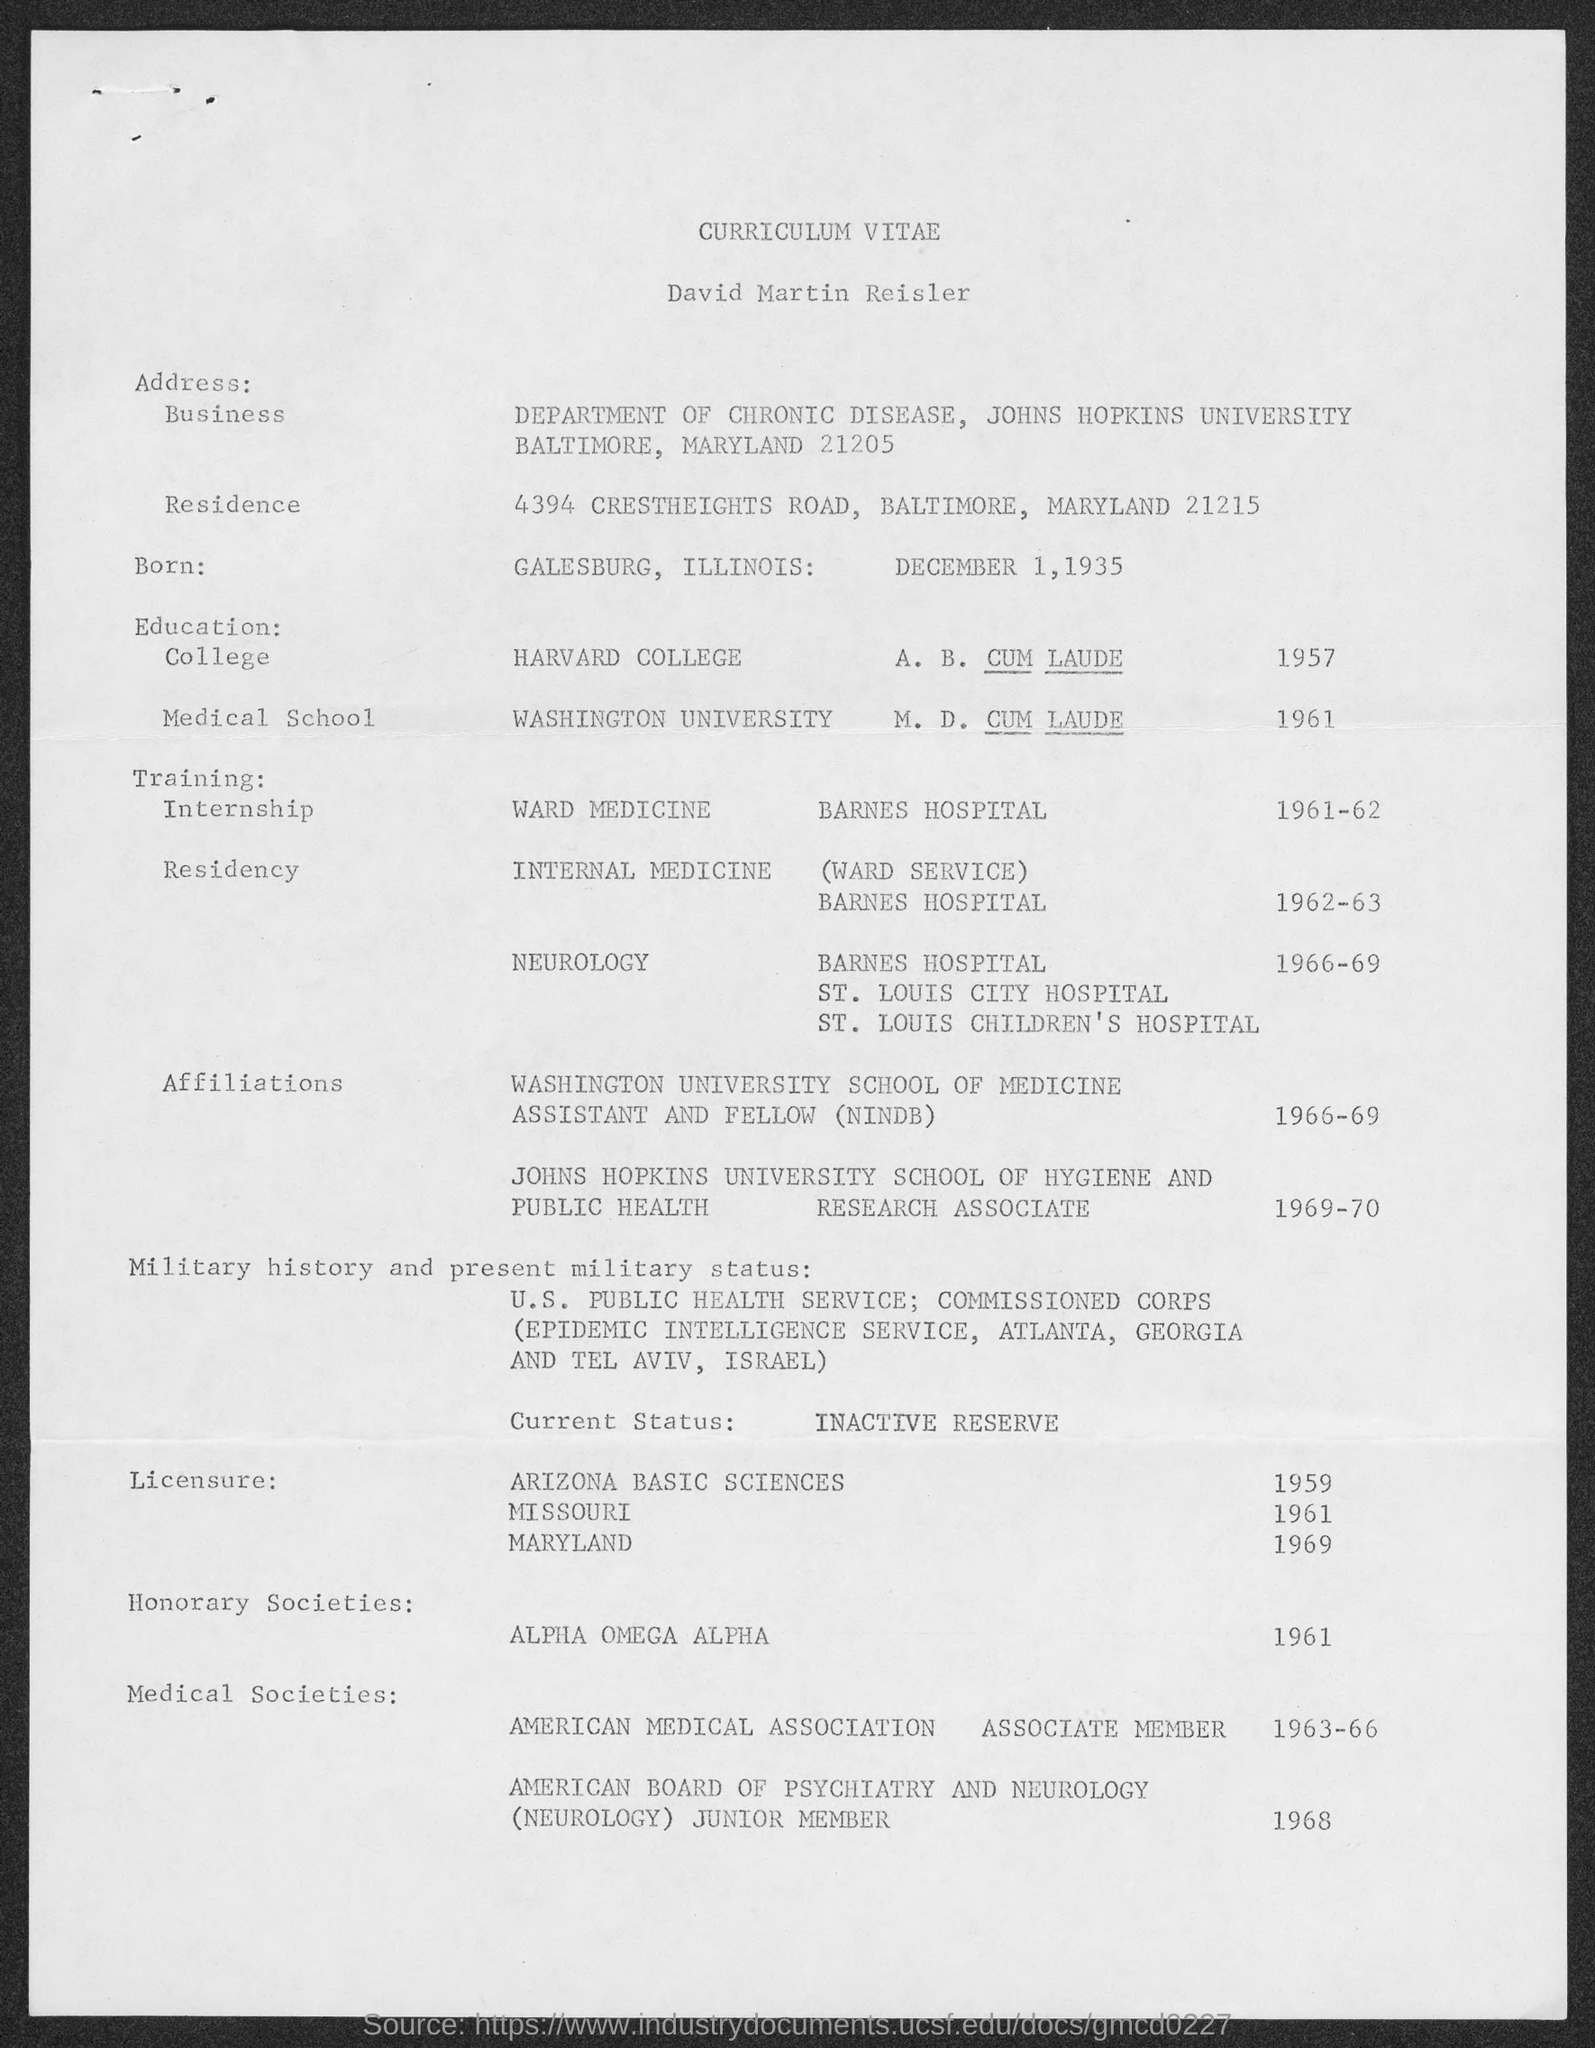Point out several critical features in this image. David Martin Reisler earned his A.B. degree from Harvard College in 1957. The curriculum vitae of David Martin Reisler is provided. David Martin Reisler completed his M.D. degree at Washington University. David Martin Reisler completed his residency in Internal Medicine at Barnes Hospital. David Martin Reisler was born on December 1, 1935. 